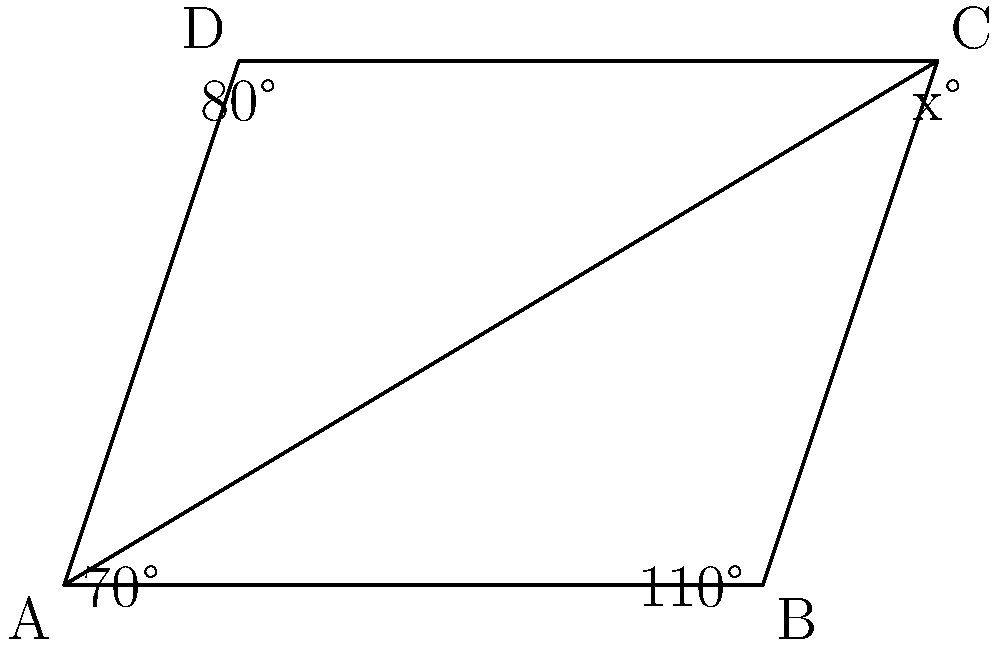In the parallelogram ABCD shown above, three angles are given: $\angle DAB = 70°$, $\angle ABC = 110°$, and $\angle ADC = 80°$. What is the measure of angle $\angle BCD$, represented by $x°$? To find the missing angle in a parallelogram, we can follow these steps:

1. Recall that in a parallelogram, opposite angles are congruent.

2. The sum of angles in a quadrilateral is always 360°.

3. We can set up an equation:
   $70° + 110° + x° + 80° = 360°$

4. Simplify:
   $260° + x° = 360°$

5. Subtract 260° from both sides:
   $x° = 360° - 260° = 100°$

Therefore, the measure of angle $\angle BCD$ is 100°.

This approach helps students with Asperger's Syndrome by breaking down the problem into clear, logical steps and using the properties of parallelograms they've learned.
Answer: 100° 